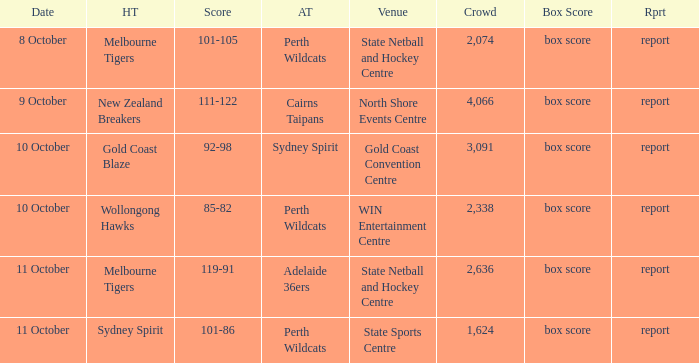What was the average crowd size for the game when the Gold Coast Blaze was the home team? 3091.0. 